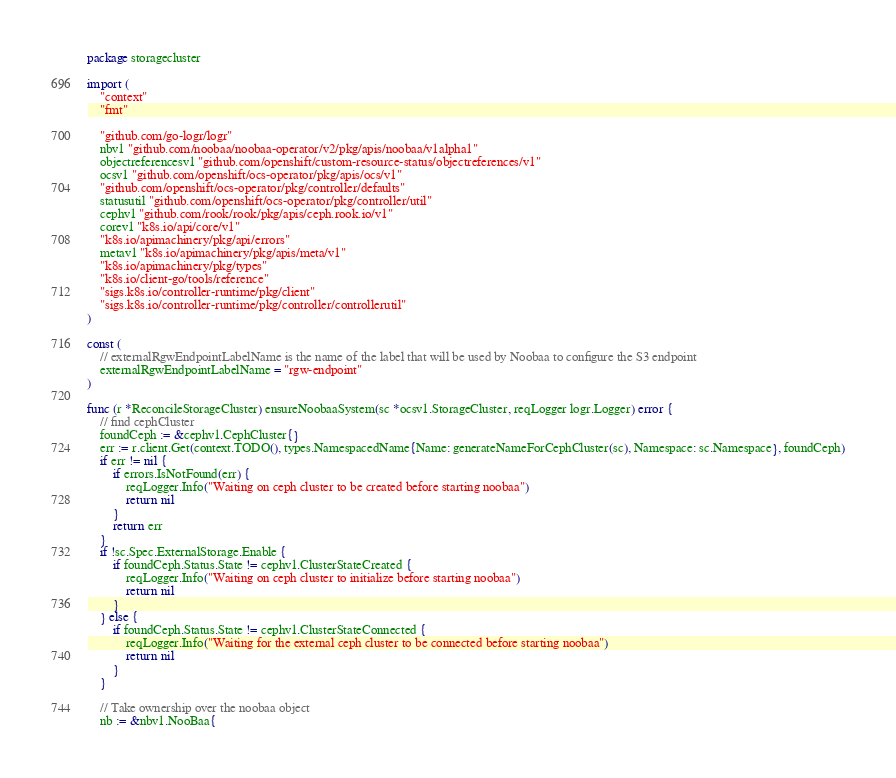Convert code to text. <code><loc_0><loc_0><loc_500><loc_500><_Go_>package storagecluster

import (
	"context"
	"fmt"

	"github.com/go-logr/logr"
	nbv1 "github.com/noobaa/noobaa-operator/v2/pkg/apis/noobaa/v1alpha1"
	objectreferencesv1 "github.com/openshift/custom-resource-status/objectreferences/v1"
	ocsv1 "github.com/openshift/ocs-operator/pkg/apis/ocs/v1"
	"github.com/openshift/ocs-operator/pkg/controller/defaults"
	statusutil "github.com/openshift/ocs-operator/pkg/controller/util"
	cephv1 "github.com/rook/rook/pkg/apis/ceph.rook.io/v1"
	corev1 "k8s.io/api/core/v1"
	"k8s.io/apimachinery/pkg/api/errors"
	metav1 "k8s.io/apimachinery/pkg/apis/meta/v1"
	"k8s.io/apimachinery/pkg/types"
	"k8s.io/client-go/tools/reference"
	"sigs.k8s.io/controller-runtime/pkg/client"
	"sigs.k8s.io/controller-runtime/pkg/controller/controllerutil"
)

const (
	// externalRgwEndpointLabelName is the name of the label that will be used by Noobaa to configure the S3 endpoint
	externalRgwEndpointLabelName = "rgw-endpoint"
)

func (r *ReconcileStorageCluster) ensureNoobaaSystem(sc *ocsv1.StorageCluster, reqLogger logr.Logger) error {
	// find cephCluster
	foundCeph := &cephv1.CephCluster{}
	err := r.client.Get(context.TODO(), types.NamespacedName{Name: generateNameForCephCluster(sc), Namespace: sc.Namespace}, foundCeph)
	if err != nil {
		if errors.IsNotFound(err) {
			reqLogger.Info("Waiting on ceph cluster to be created before starting noobaa")
			return nil
		}
		return err
	}
	if !sc.Spec.ExternalStorage.Enable {
		if foundCeph.Status.State != cephv1.ClusterStateCreated {
			reqLogger.Info("Waiting on ceph cluster to initialize before starting noobaa")
			return nil
		}
	} else {
		if foundCeph.Status.State != cephv1.ClusterStateConnected {
			reqLogger.Info("Waiting for the external ceph cluster to be connected before starting noobaa")
			return nil
		}
	}

	// Take ownership over the noobaa object
	nb := &nbv1.NooBaa{</code> 